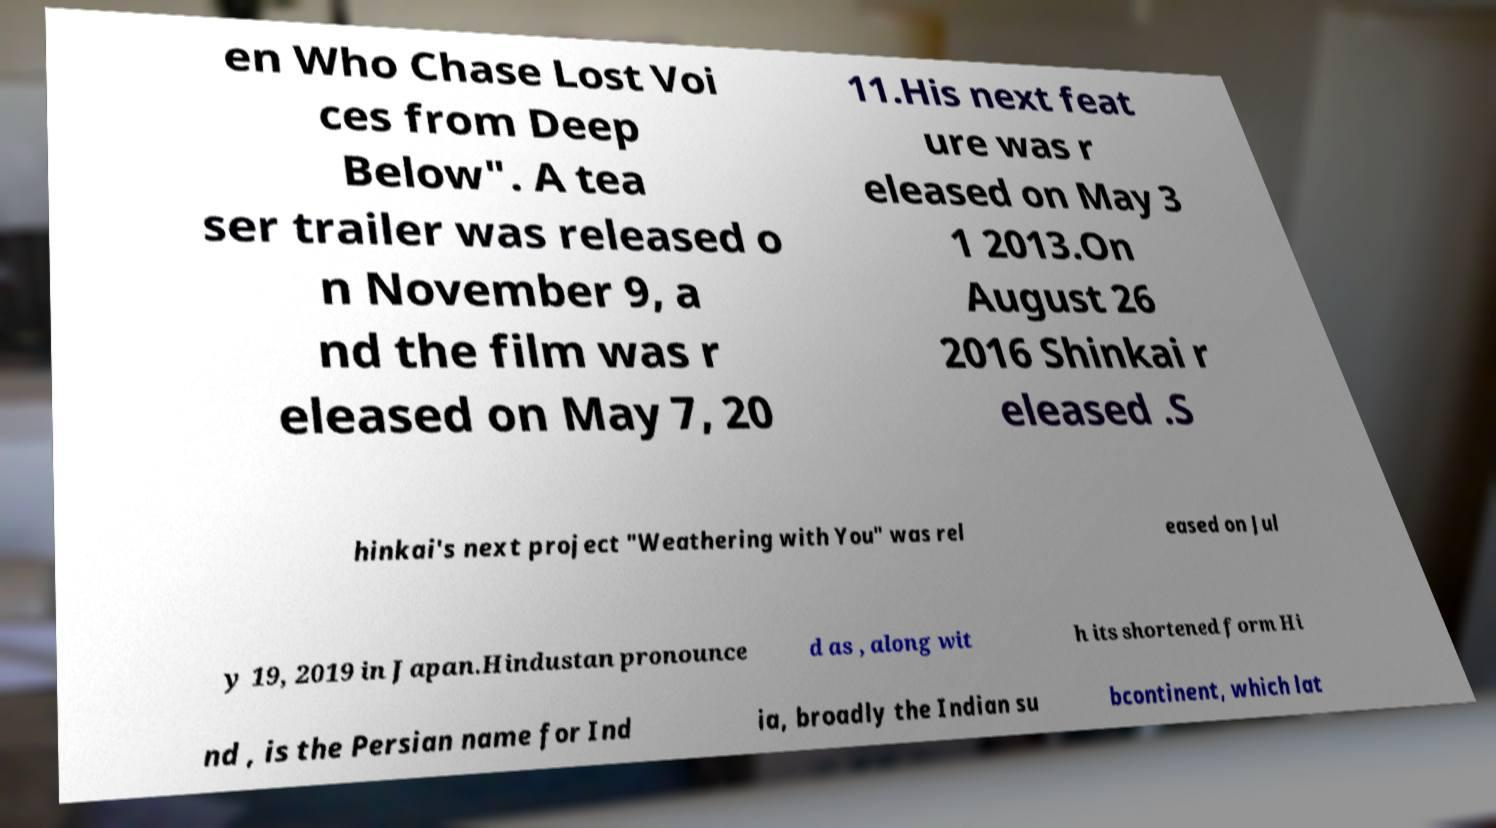Could you assist in decoding the text presented in this image and type it out clearly? en Who Chase Lost Voi ces from Deep Below". A tea ser trailer was released o n November 9, a nd the film was r eleased on May 7, 20 11.His next feat ure was r eleased on May 3 1 2013.On August 26 2016 Shinkai r eleased .S hinkai's next project "Weathering with You" was rel eased on Jul y 19, 2019 in Japan.Hindustan pronounce d as , along wit h its shortened form Hi nd , is the Persian name for Ind ia, broadly the Indian su bcontinent, which lat 